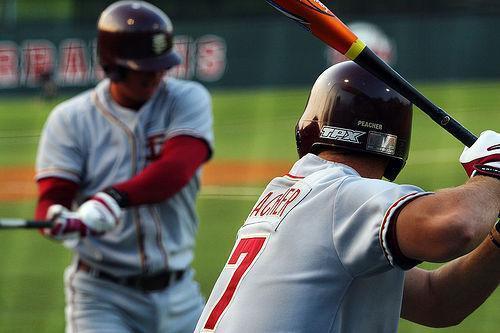How many people can you see?
Give a very brief answer. 2. 